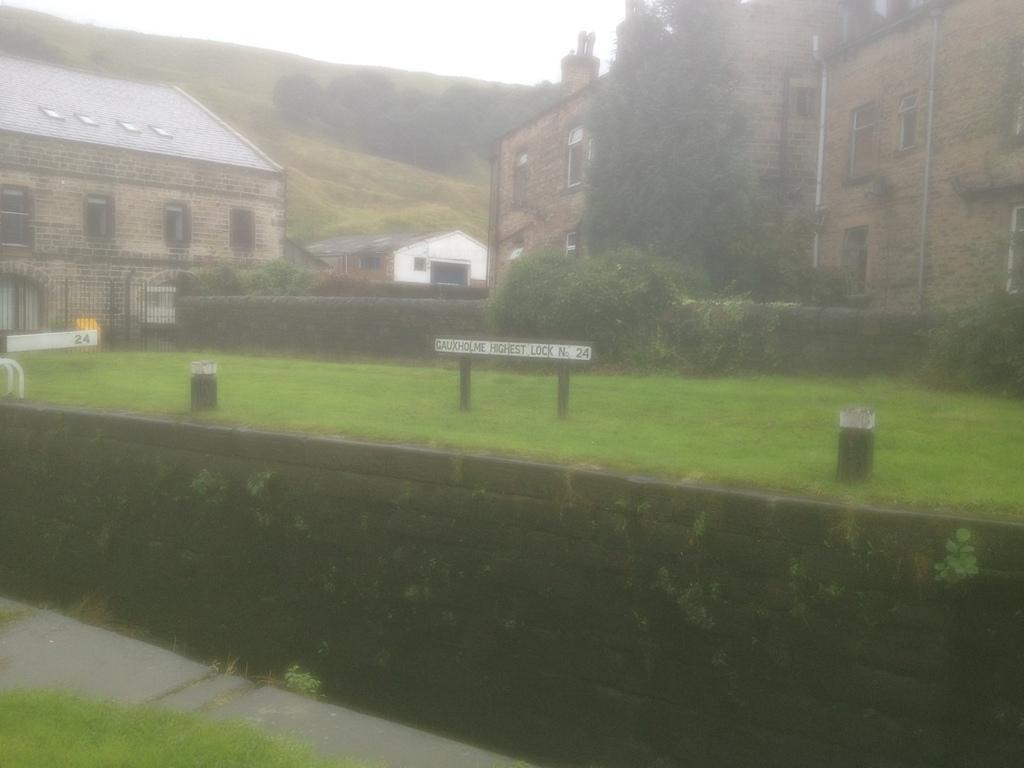Can you describe this image briefly? In this image I can see buildings, the grass, trees, plants and some other objects on the ground. In the background I can see trees and the sky. 